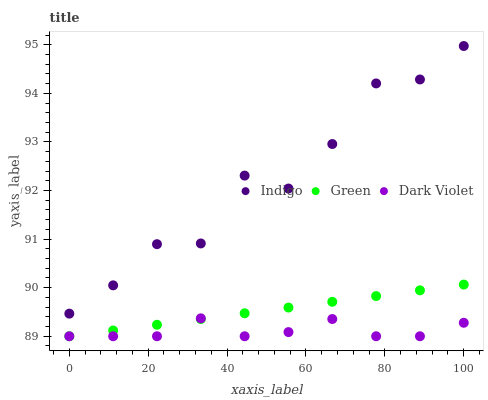Does Dark Violet have the minimum area under the curve?
Answer yes or no. Yes. Does Indigo have the maximum area under the curve?
Answer yes or no. Yes. Does Indigo have the minimum area under the curve?
Answer yes or no. No. Does Dark Violet have the maximum area under the curve?
Answer yes or no. No. Is Green the smoothest?
Answer yes or no. Yes. Is Indigo the roughest?
Answer yes or no. Yes. Is Dark Violet the smoothest?
Answer yes or no. No. Is Dark Violet the roughest?
Answer yes or no. No. Does Green have the lowest value?
Answer yes or no. Yes. Does Indigo have the lowest value?
Answer yes or no. No. Does Indigo have the highest value?
Answer yes or no. Yes. Does Dark Violet have the highest value?
Answer yes or no. No. Is Dark Violet less than Indigo?
Answer yes or no. Yes. Is Indigo greater than Dark Violet?
Answer yes or no. Yes. Does Green intersect Dark Violet?
Answer yes or no. Yes. Is Green less than Dark Violet?
Answer yes or no. No. Is Green greater than Dark Violet?
Answer yes or no. No. Does Dark Violet intersect Indigo?
Answer yes or no. No. 